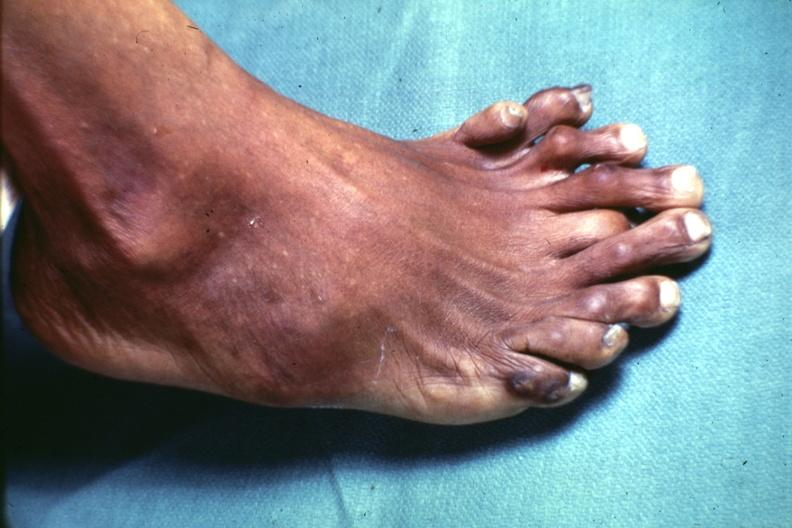does this image show view from dorsum of foot which has at least 9 toes?
Answer the question using a single word or phrase. Yes 